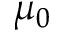<formula> <loc_0><loc_0><loc_500><loc_500>\mu _ { 0 }</formula> 